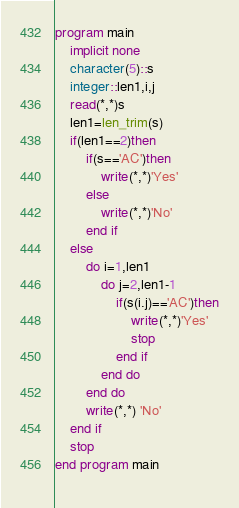<code> <loc_0><loc_0><loc_500><loc_500><_FORTRAN_>program main
	implicit none
    character(5)::s
    integer::len1,i,j
    read(*,*)s
    len1=len_trim(s)
    if(len1==2)then
    	if(s=='AC')then
        	write(*,*)'Yes'
        else
        	write(*,*)'No'
        end if
    else
    	do i=1,len1
    		do j=2,len1-1
            	if(s(i.j)=='AC')then
                	write(*,*)'Yes'
                    stop
                end if
            end do
        end do
        write(*,*) 'No'
    end if
    stop
end program main
    </code> 